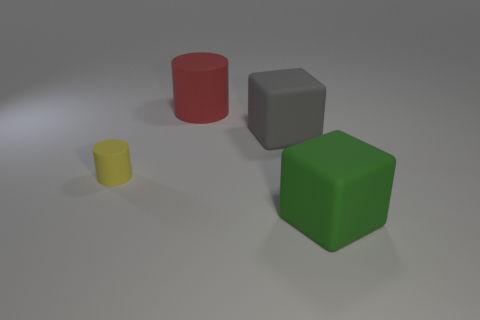Add 2 small yellow spheres. How many objects exist? 6 Add 1 cylinders. How many cylinders exist? 3 Subtract 0 brown cylinders. How many objects are left? 4 Subtract all tiny cyan metal blocks. Subtract all matte objects. How many objects are left? 0 Add 2 big green cubes. How many big green cubes are left? 3 